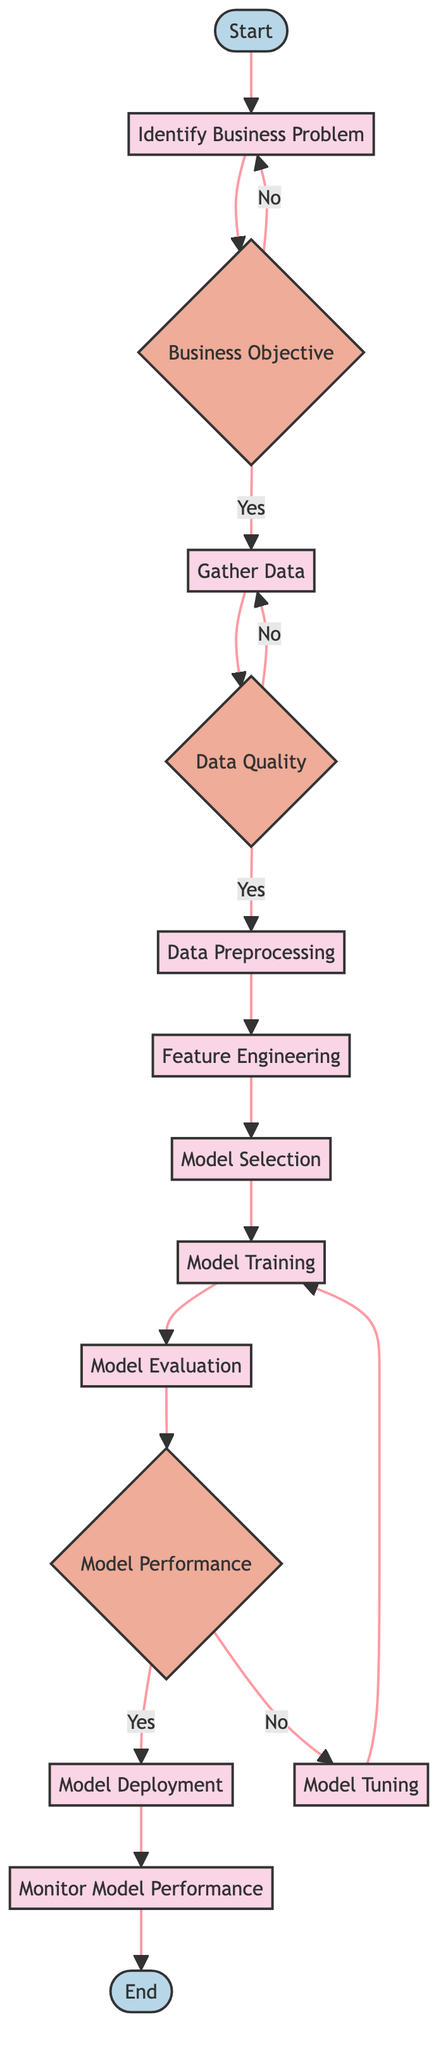What is the first action in the workflow? The first action in the workflow is "Identify Business Problem," which is the action that starts the entire process of implementing a predictive model.
Answer: Identify Business Problem How many decision points are in the diagram? There are three decision points in the diagram: "Business Objective," "Data Quality," and "Model Performance." This reflects a total count of decision nodes in the workflow.
Answer: 3 What is the last action before reaching the end of the workflow? The last action before reaching the end of the workflow is "Monitor Model Performance." This action comes just before the workflow concludes at the end node.
Answer: Monitor Model Performance What happens if the business objective is not clear? If the business objective is not clear ("No" response to "Business Objective"), the workflow loops back to the action "Identify Business Problem," indicating a need to clarify the business challenge before proceeding.
Answer: Identify Business Problem Which action leads to "Model Deployment"? The action that leads to "Model Deployment" is "Model Evaluation." Once the model's performance is deemed acceptable, the next step is to deploy it within the business application.
Answer: Model Evaluation What is the relationship between "Model Performance" and "Model Tuning"? The relationship is that if the model's performance is not acceptable ("No" response to "Model Performance"), the workflow transitions to "Model Tuning" to optimize the model's parameters before returning to "Model Training."
Answer: Model Tuning What do you do after gathering data? After gathering data, you proceed to the action "Data Preprocessing," which involves cleaning and transforming the collected data in preparation for modeling.
Answer: Data Preprocessing What decision must be made before data preprocessing? The decision that must be made before "Data Preprocessing" is regarding "Data Quality." It assesses if the collected data is of high quality, which is crucial for effective modeling.
Answer: Data Quality 